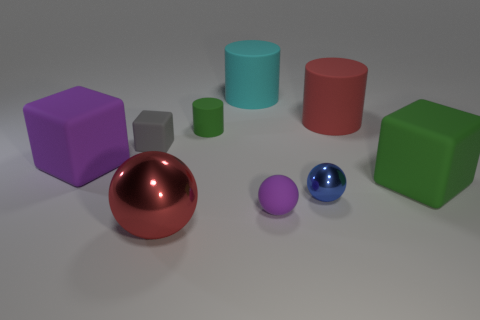Subtract 2 blocks. How many blocks are left? 1 Subtract all large matte cubes. How many cubes are left? 1 Add 1 big cyan shiny spheres. How many objects exist? 10 Subtract all yellow cubes. How many cyan cylinders are left? 1 Add 5 green rubber cylinders. How many green rubber cylinders are left? 6 Add 8 big gray balls. How many big gray balls exist? 8 Subtract all gray cubes. How many cubes are left? 2 Subtract 1 purple blocks. How many objects are left? 8 Subtract all cubes. How many objects are left? 6 Subtract all yellow spheres. Subtract all purple cylinders. How many spheres are left? 3 